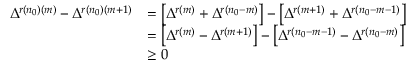Convert formula to latex. <formula><loc_0><loc_0><loc_500><loc_500>\begin{array} { r l } { \Delta ^ { r ( n _ { 0 } ) ( m ) } - \Delta ^ { r ( n _ { 0 } ) ( m + 1 ) } } & { = \left [ \Delta ^ { r ( m ) } + \Delta ^ { r ( n _ { 0 } - m ) } \right ] - \left [ \Delta ^ { r ( m + 1 ) } + \Delta ^ { r ( n _ { 0 } - m - 1 ) } \right ] } \\ & { = \left [ \Delta ^ { r ( m ) } - \Delta ^ { r ( m + 1 ) } \right ] - \left [ \Delta ^ { r ( n _ { 0 } - m - 1 ) } - \Delta ^ { r ( n _ { 0 } - m ) } \right ] } \\ & { \geq 0 } \end{array}</formula> 